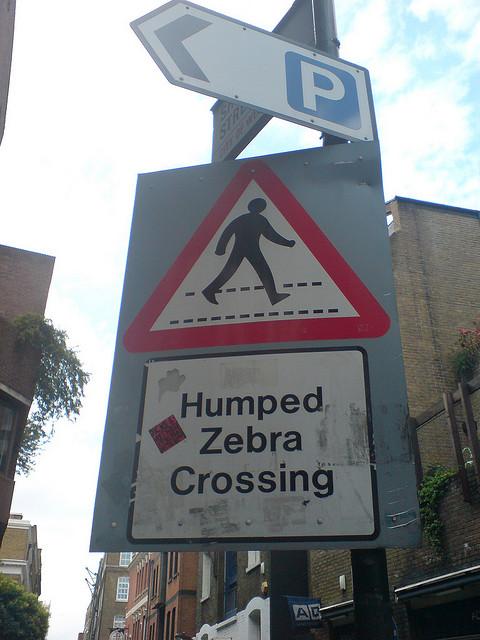What language are the signs written in?
Short answer required. English. What do both of these signs say?
Be succinct. Humped zebra crossing. What sign is seen?
Quick response, please. Zebra crossing. What shape is the main sign?
Quick response, please. Square. Is the sign yellow?
Short answer required. No. What are they pictures on the sign?
Write a very short answer. Person. How many signs are there?
Give a very brief answer. 3. What is the arrow directing you to?
Short answer required. Parking. What country is this?
Concise answer only. Australia. Are there lots of trees in the photo?
Concise answer only. No. Which way is the arrow pointing?
Keep it brief. Left. How many signs are connected?
Concise answer only. 3. Where is the tree with green leaves?
Answer briefly. On left. How many Pedestrian icons are there in that picture?
Be succinct. 1. What does the sign say?
Quick response, please. Humped zebra crossing. What kind of person is depicted on the sign?
Keep it brief. Pedestrian. What words are on the bottom sign?
Be succinct. Humped zebra crossing. What shape is the red sign?
Be succinct. Triangle. What is the sign saying?
Answer briefly. Humped zebra crossing. What kind of silhouette is on the sign?
Concise answer only. Person. What does the bicycle sign say?
Give a very brief answer. Humped zebra crossing. Is parking to the left or right?
Concise answer only. Left. Why is the bottom sign funny?
Keep it brief. I don't know. Can you cross on this street?
Keep it brief. Yes. Can you get a drink close by?
Concise answer only. No. What sign is the sign pointing to?
Short answer required. Parking. 